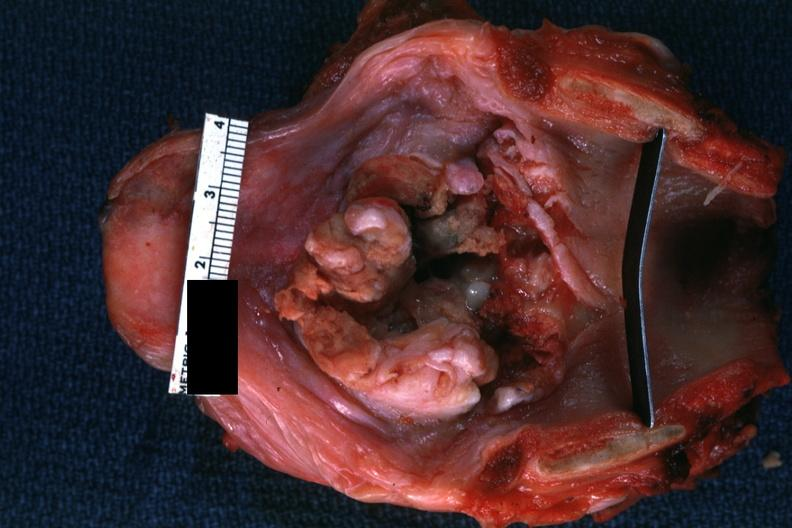does malignant lymphoma large cell type show large lesion good but not the best?
Answer the question using a single word or phrase. No 